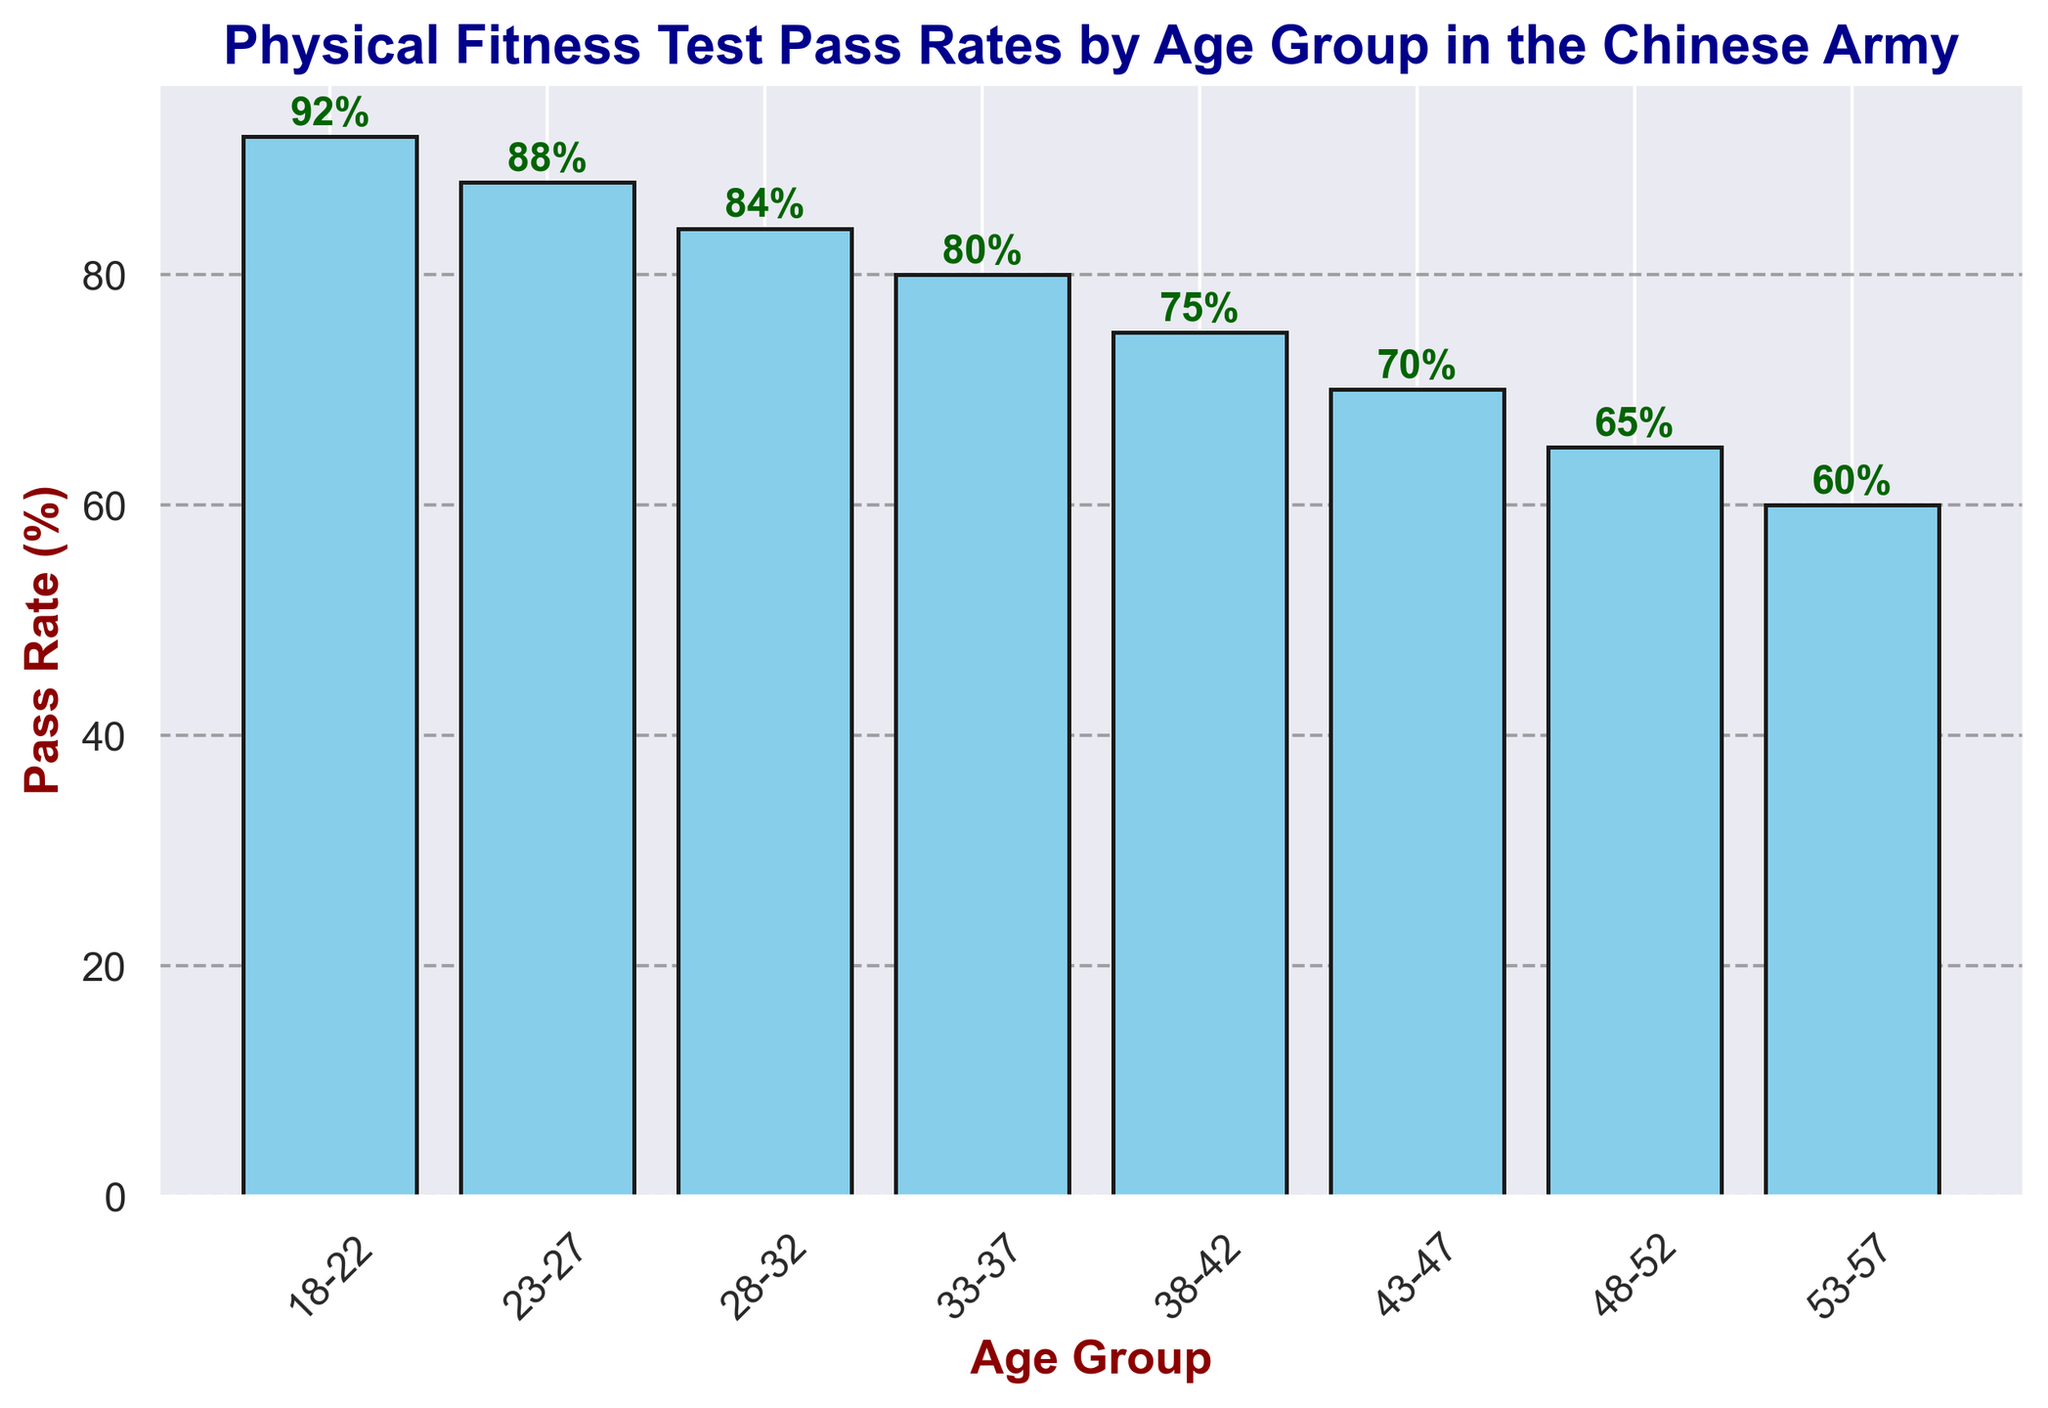Which age group has the highest pass rate in the physical fitness test? The highest bar in the chart represents the age group 18-22, with a pass rate of 92%. The title of the chart indicates that it reflects pass rates by age group in the Chinese army.
Answer: 18-22 Which age group has the lowest pass rate in the physical fitness test? The shortest bar in the chart represents the age group 53-57, with a pass rate of 60%.
Answer: 53-57 What is the difference in pass rates between the age groups 23-27 and 33-37? The pass rate for the age group 23-27 is 88%, and for the age group 33-37, it is 80%. The difference is calculated as 88% - 80% = 8%.
Answer: 8% What is the average pass rate of the age groups 28-32, 33-37, and 38-42? Retrieve the pass rates for the age groups 28-32 (84%), 33-37 (80%), and 38-42 (75%). The sum is 84% + 80% + 75% = 239%. The average is 239% / 3 = 79.67%.
Answer: 79.67% Which two consecutive age groups show the biggest drop in pass rates? By examining the differences between consecutive age groups: 
(18-22 to 23-27): 92% - 88% = 4%
(23-27 to 28-32): 88% - 84% = 4%
(28-32 to 33-37): 84% - 80% = 4%
(33-37 to 38-42): 80% - 75% = 5%
(38-42 to 43-47): 75% - 70% = 5%
(43-47 to 48-52): 70% - 65% = 5%
(48-52 to 53-57): 65% - 60% = 5%
The biggest drop is 5%, occurring between 33-37 to 38-42, 38-42 to 43-47, 43-47 to 48-52, and 48-52 to 53-57.
Answer: 33-37 to 38-42, 38-42 to 43-47, 43-47 to 48-52, 48-52 to 53-57 How does the pass rate change visually as the age group increases? Visually, the height of the bars decreases as the age groups increase. The first bar (18-22) is the tallest and each subsequent bar is shorter, indicating a decrease in pass rates.
Answer: Decreases Is there any age group with a pass rate below 70%? The chart indicates that the age group 48-52 has a pass rate of 65%, and the age group 53-57 has a pass rate of 60%, both of which are below 70%.
Answer: Yes How many age groups have pass rates between 80% and 90%? The age groups with pass rates between 80% and 90% are 23-27 (88%), 28-32 (84%), and 33-37 (80%). This results in a total of 3 age groups.
Answer: 3 What is the total pass rate of the age groups 18-22, 23-27, and 28-32 combined? The pass rates for the age groups 18-22, 23-27, and 28-32 are 92%, 88%, and 84%, respectively. The total pass rate is the sum of these rates: 92% + 88% + 84% = 264%.
Answer: 264% What is the median pass rate of all age groups? Organize the pass rates in ascending order: 60%, 65%, 70%, 75%, 80%, 84%, 88%, 92%. With eight values, the median is the average of the 4th and 5th values: (75% + 80%) / 2 = 77.5%.
Answer: 77.5% 